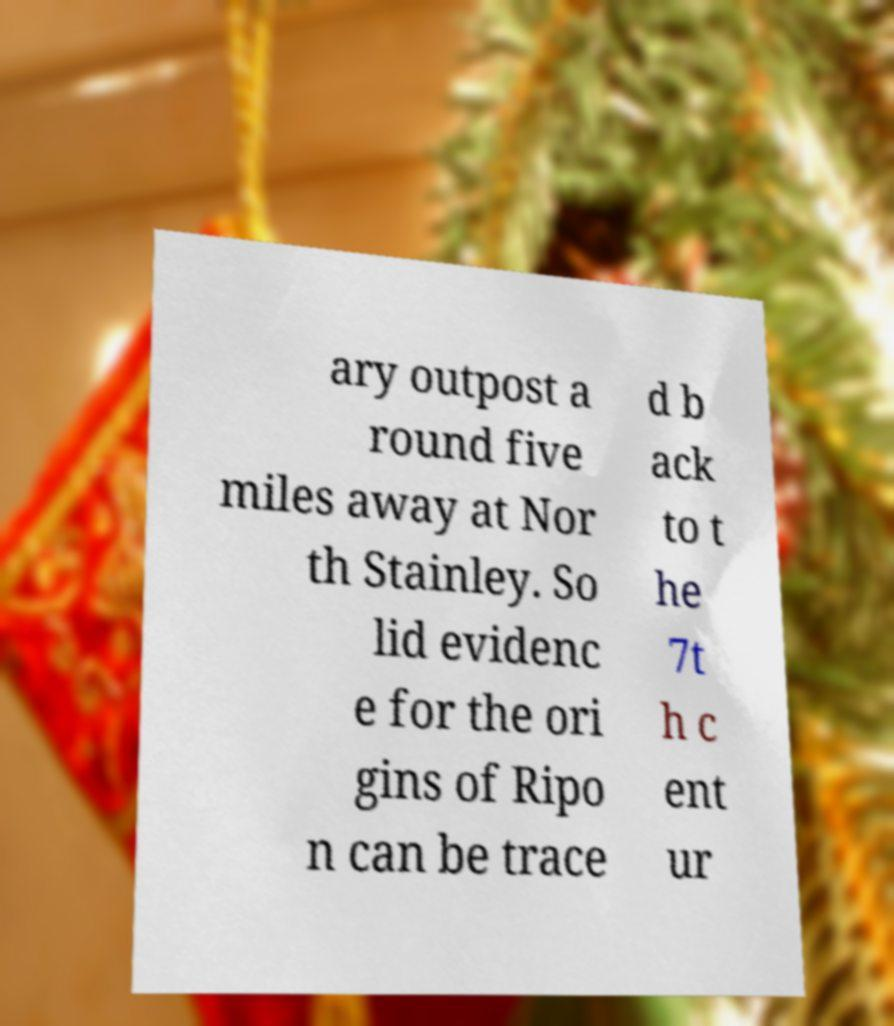Please read and relay the text visible in this image. What does it say? ary outpost a round five miles away at Nor th Stainley. So lid evidenc e for the ori gins of Ripo n can be trace d b ack to t he 7t h c ent ur 